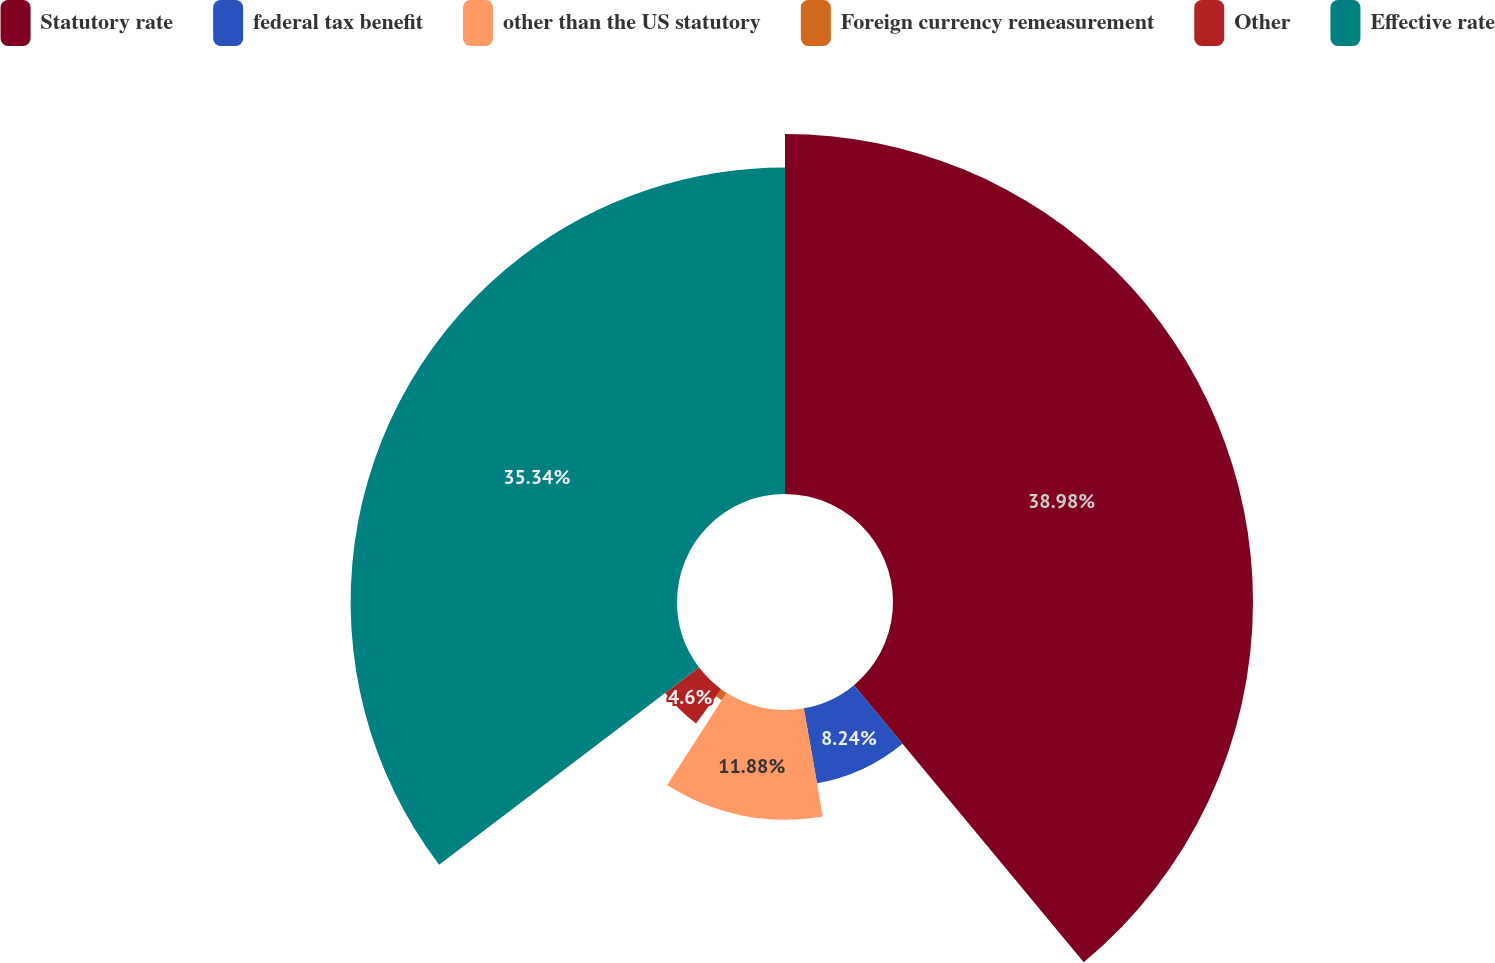Convert chart to OTSL. <chart><loc_0><loc_0><loc_500><loc_500><pie_chart><fcel>Statutory rate<fcel>federal tax benefit<fcel>other than the US statutory<fcel>Foreign currency remeasurement<fcel>Other<fcel>Effective rate<nl><fcel>38.98%<fcel>8.24%<fcel>11.88%<fcel>0.96%<fcel>4.6%<fcel>35.34%<nl></chart> 